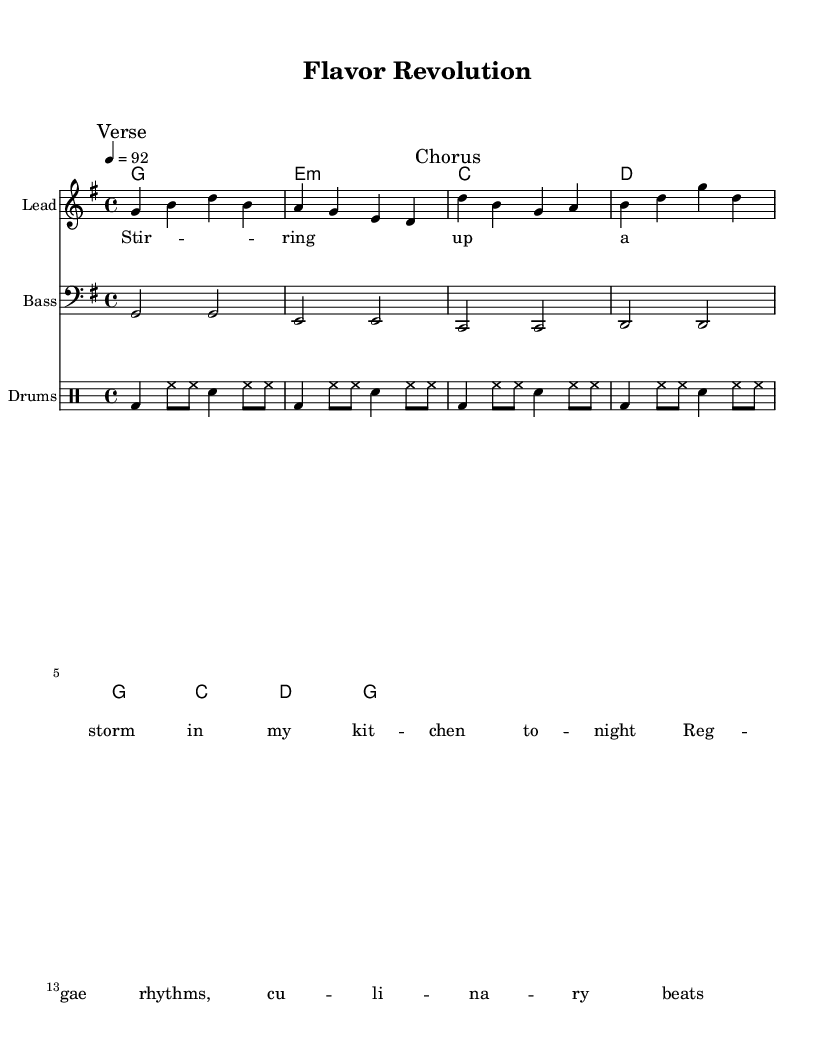What is the key signature of this music? The key signature is G major, which has one sharp (F#). You can identify the key signature by looking at the beginning of the staff before the notes.
Answer: G major What is the time signature of this piece? The time signature is 4/4, indicating four beats in each measure and a quarter note receives one beat. This can be found at the beginning of the music, next to the key signature.
Answer: 4/4 What is the tempo marking in the score? The tempo marking is 4 = 92, which indicates that the quarter note is to be played at 92 beats per minute. This is shown in the tempo indication at the beginning of the score.
Answer: 92 Name the instruments used in this score. The instruments used are Lead for the melody, Bass for the bass line, and Drums for the rhythm section. This information is found in the staff labels at the beginning of each part.
Answer: Lead, Bass, Drums How many measures are in the verse section? The verse section contains four measures. You can count the vertical lines indicating the end of each measure in the verse music.
Answer: 4 What is the structure of the song indicated on the score? The structure consists of a Verse followed by a Chorus. This is indicated by the markings placed on the score at the relevant sections.
Answer: Verse, Chorus How do the rhythms in the drums part contribute to the reggae feel? The rhythms use a consistent pattern of bass drum, hi-hat, and snare that create a laid-back groove typical of reggae music, emphasizing the off-beat, which can be understood through the specific drum notations and their placement.
Answer: Off-beat groove 